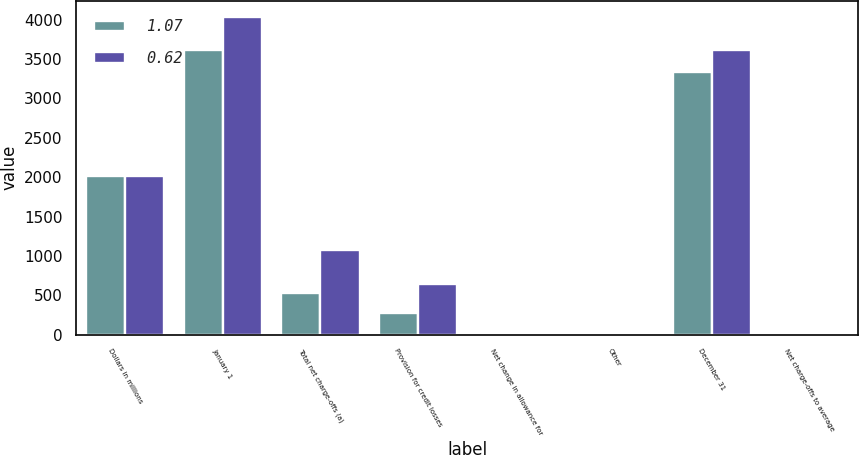Convert chart. <chart><loc_0><loc_0><loc_500><loc_500><stacked_bar_chart><ecel><fcel>Dollars in millions<fcel>January 1<fcel>Total net charge-offs (a)<fcel>Provision for credit losses<fcel>Net change in allowance for<fcel>Other<fcel>December 31<fcel>Net charge-offs to average<nl><fcel>1.07<fcel>2014<fcel>3609<fcel>531<fcel>273<fcel>17<fcel>3<fcel>3331<fcel>0.27<nl><fcel>0.62<fcel>2013<fcel>4036<fcel>1077<fcel>643<fcel>8<fcel>1<fcel>3609<fcel>0.57<nl></chart> 